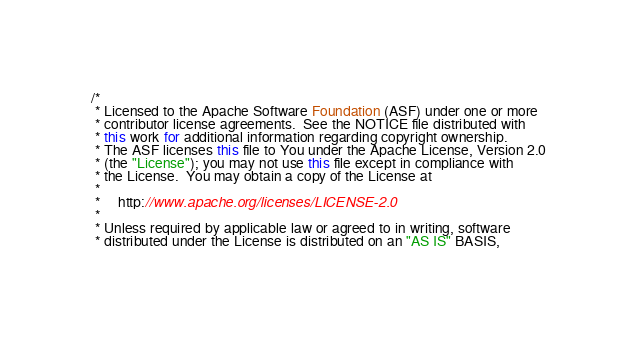Convert code to text. <code><loc_0><loc_0><loc_500><loc_500><_Java_>/*
 * Licensed to the Apache Software Foundation (ASF) under one or more
 * contributor license agreements.  See the NOTICE file distributed with
 * this work for additional information regarding copyright ownership.
 * The ASF licenses this file to You under the Apache License, Version 2.0
 * (the "License"); you may not use this file except in compliance with
 * the License.  You may obtain a copy of the License at
 *
 *     http://www.apache.org/licenses/LICENSE-2.0
 *
 * Unless required by applicable law or agreed to in writing, software
 * distributed under the License is distributed on an "AS IS" BASIS,</code> 